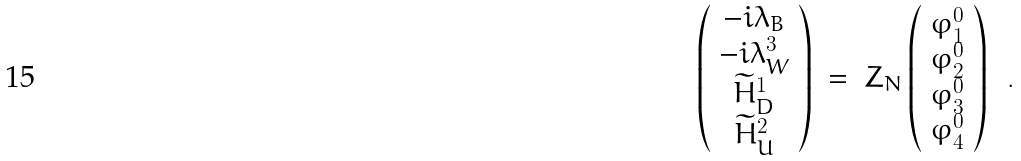<formula> <loc_0><loc_0><loc_500><loc_500>\left ( \begin{array} { c } - i \lambda _ { B } \\ - i \lambda _ { W } ^ { 3 } \\ \widetilde { H } _ { D } ^ { 1 } \\ \widetilde { H } _ { U } ^ { 2 } \end{array} \right ) \ = \ Z _ { N } \left ( \begin{array} { c } \varphi ^ { 0 } _ { 1 } \\ \varphi ^ { 0 } _ { 2 } \\ \varphi ^ { 0 } _ { 3 } \\ \varphi ^ { 0 } _ { 4 } \end{array} \right ) \ \ .</formula> 